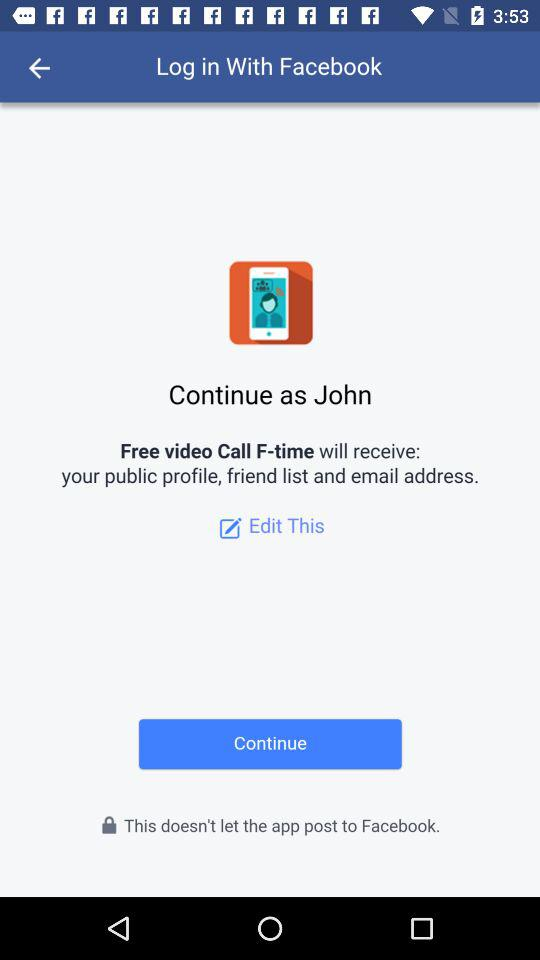What is the application name? The application name is "Free video Call F-time". 